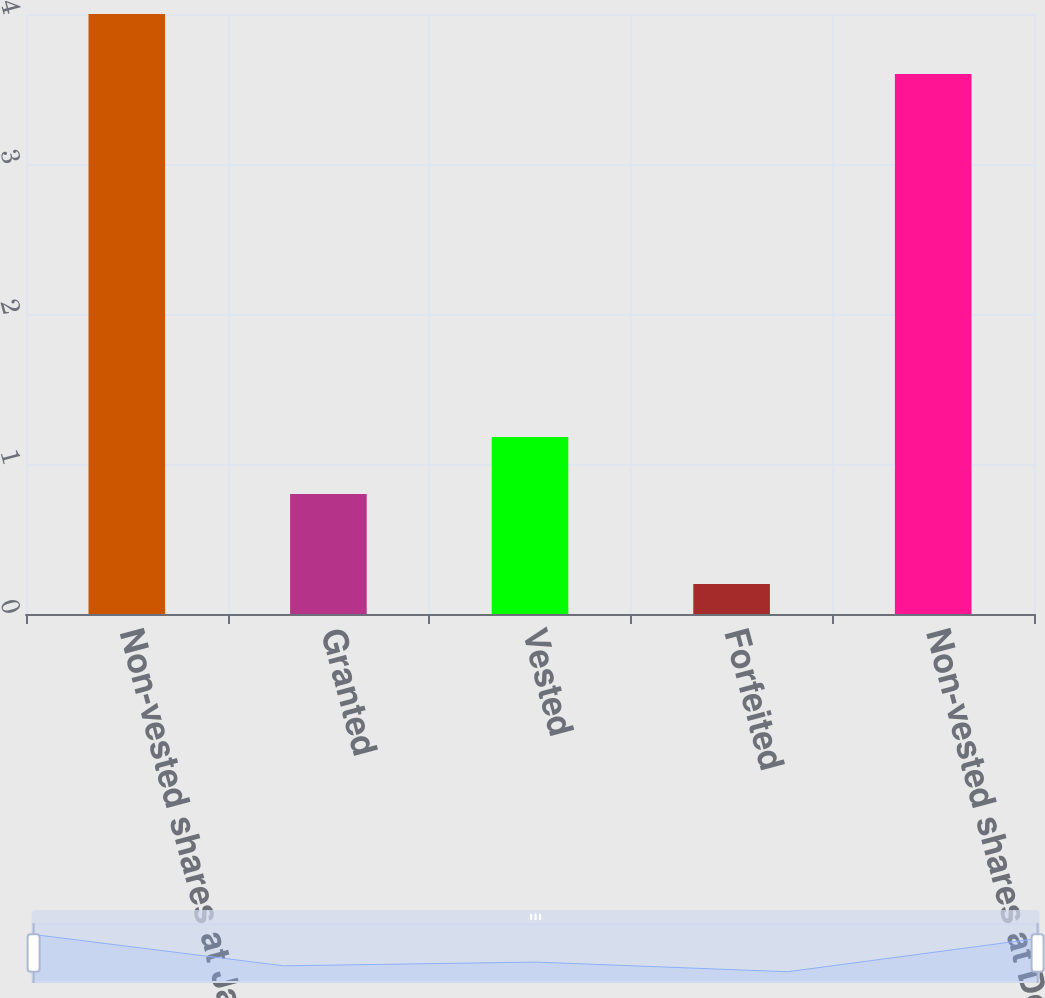Convert chart to OTSL. <chart><loc_0><loc_0><loc_500><loc_500><bar_chart><fcel>Non-vested shares at January 1<fcel>Granted<fcel>Vested<fcel>Forfeited<fcel>Non-vested shares at December<nl><fcel>4<fcel>0.8<fcel>1.18<fcel>0.2<fcel>3.6<nl></chart> 